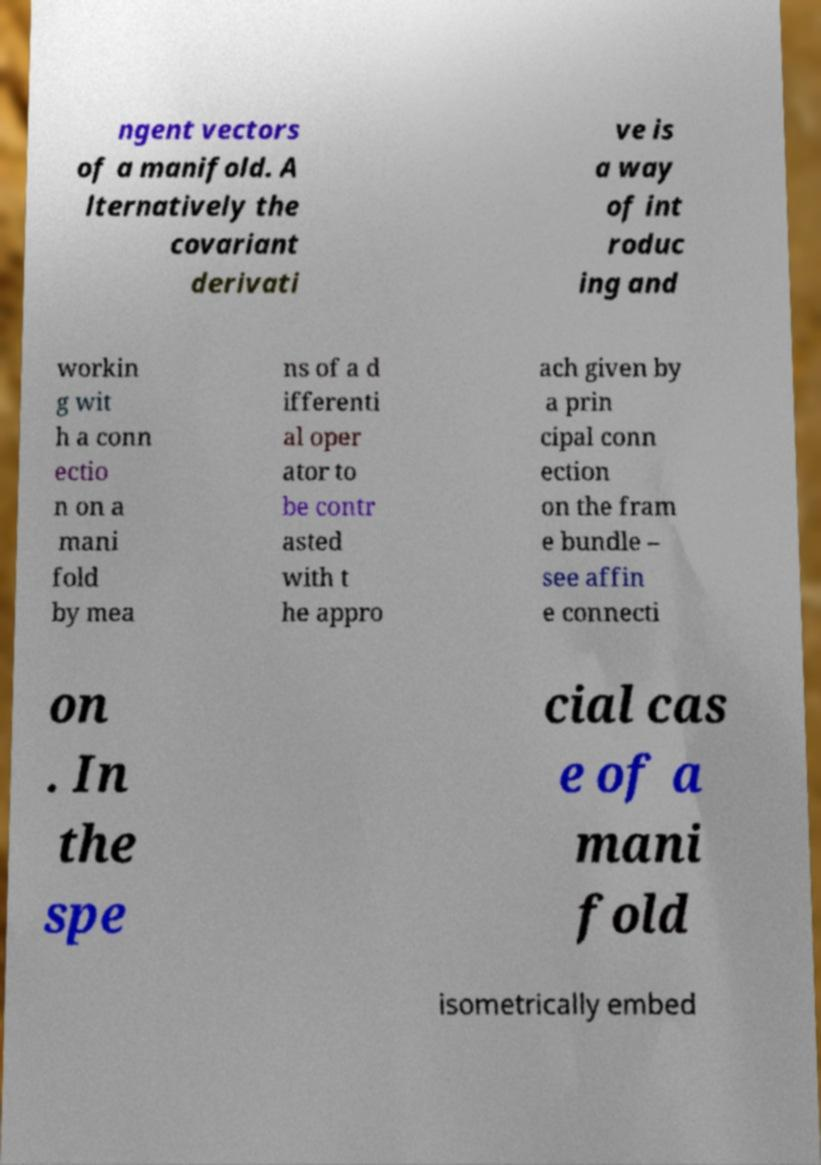Can you read and provide the text displayed in the image?This photo seems to have some interesting text. Can you extract and type it out for me? ngent vectors of a manifold. A lternatively the covariant derivati ve is a way of int roduc ing and workin g wit h a conn ectio n on a mani fold by mea ns of a d ifferenti al oper ator to be contr asted with t he appro ach given by a prin cipal conn ection on the fram e bundle – see affin e connecti on . In the spe cial cas e of a mani fold isometrically embed 